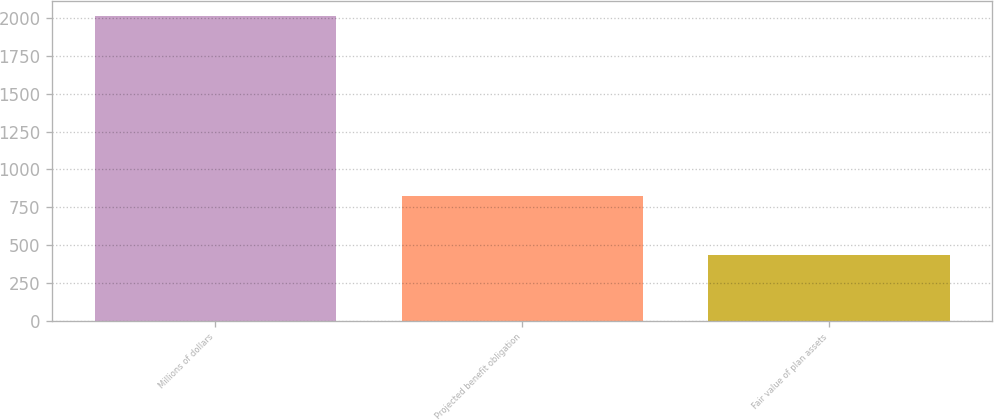Convert chart. <chart><loc_0><loc_0><loc_500><loc_500><bar_chart><fcel>Millions of dollars<fcel>Projected benefit obligation<fcel>Fair value of plan assets<nl><fcel>2017<fcel>822<fcel>437<nl></chart> 